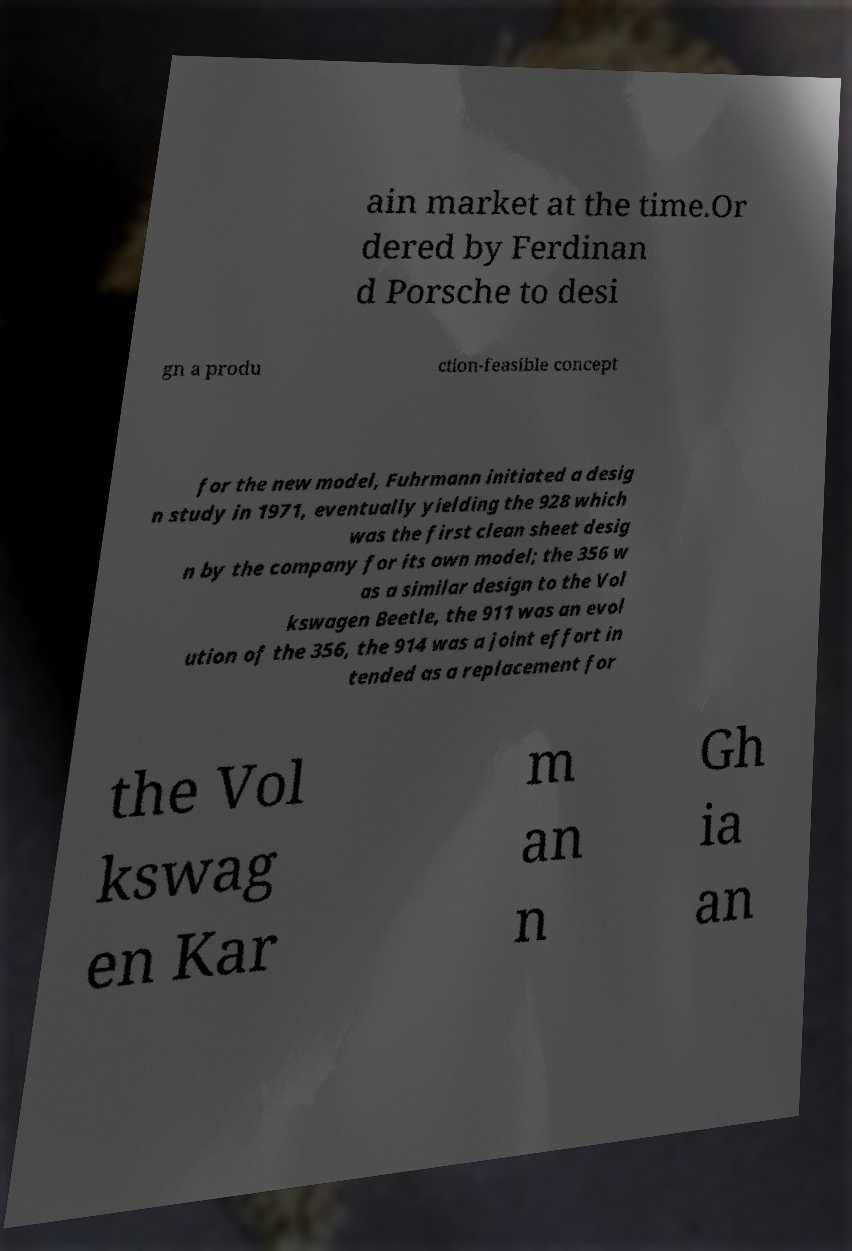Please read and relay the text visible in this image. What does it say? ain market at the time.Or dered by Ferdinan d Porsche to desi gn a produ ction-feasible concept for the new model, Fuhrmann initiated a desig n study in 1971, eventually yielding the 928 which was the first clean sheet desig n by the company for its own model; the 356 w as a similar design to the Vol kswagen Beetle, the 911 was an evol ution of the 356, the 914 was a joint effort in tended as a replacement for the Vol kswag en Kar m an n Gh ia an 